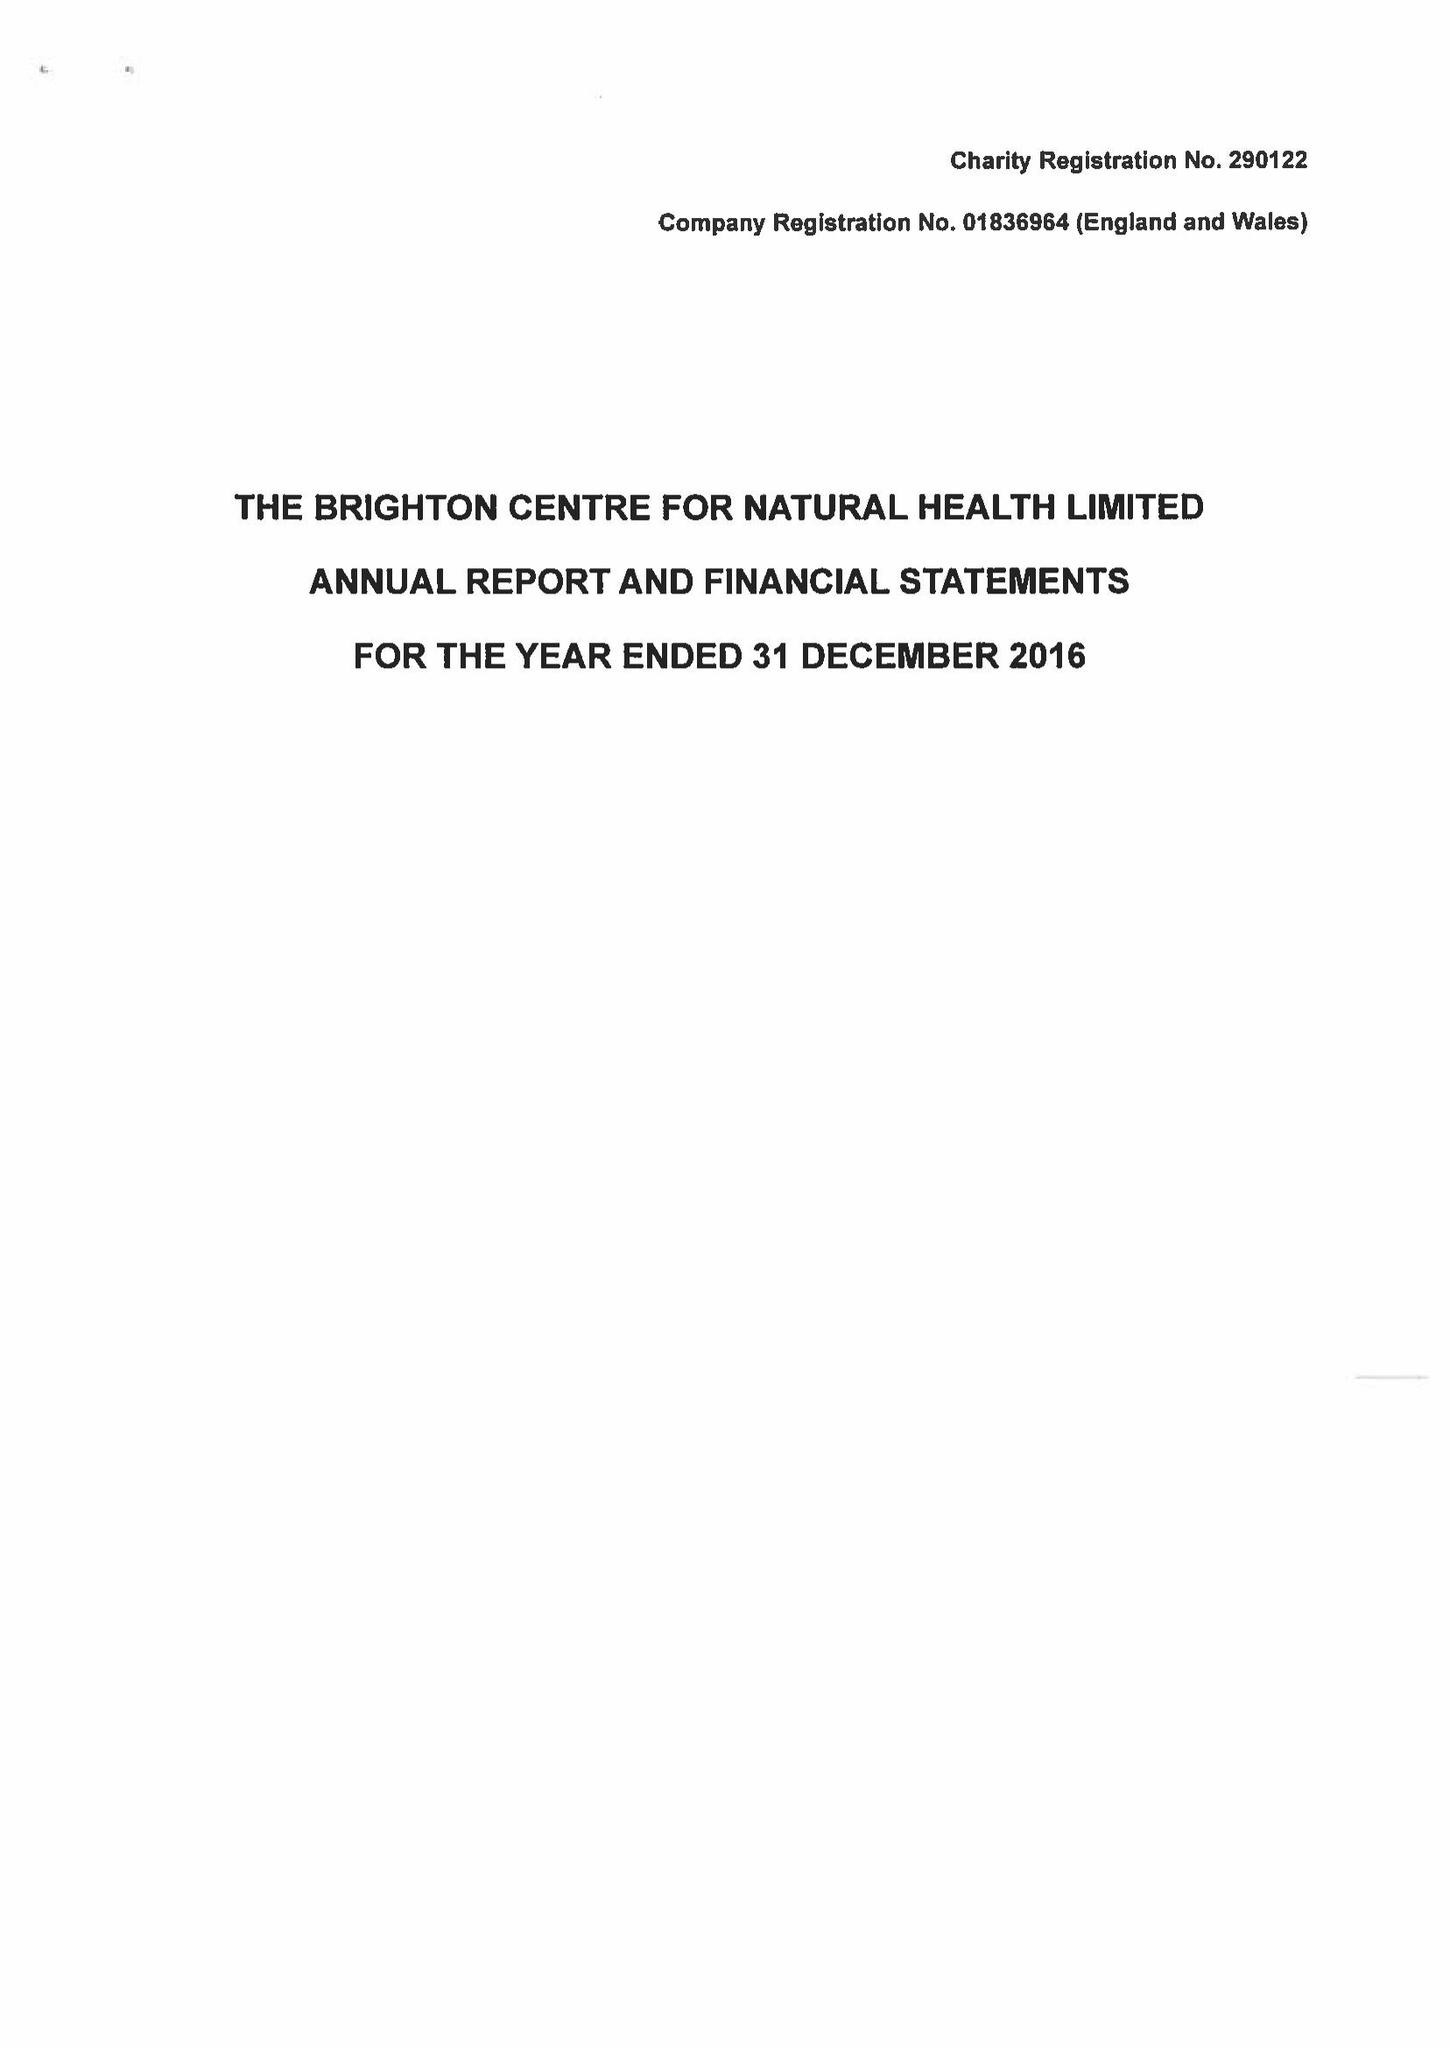What is the value for the income_annually_in_british_pounds?
Answer the question using a single word or phrase. 223733.00 